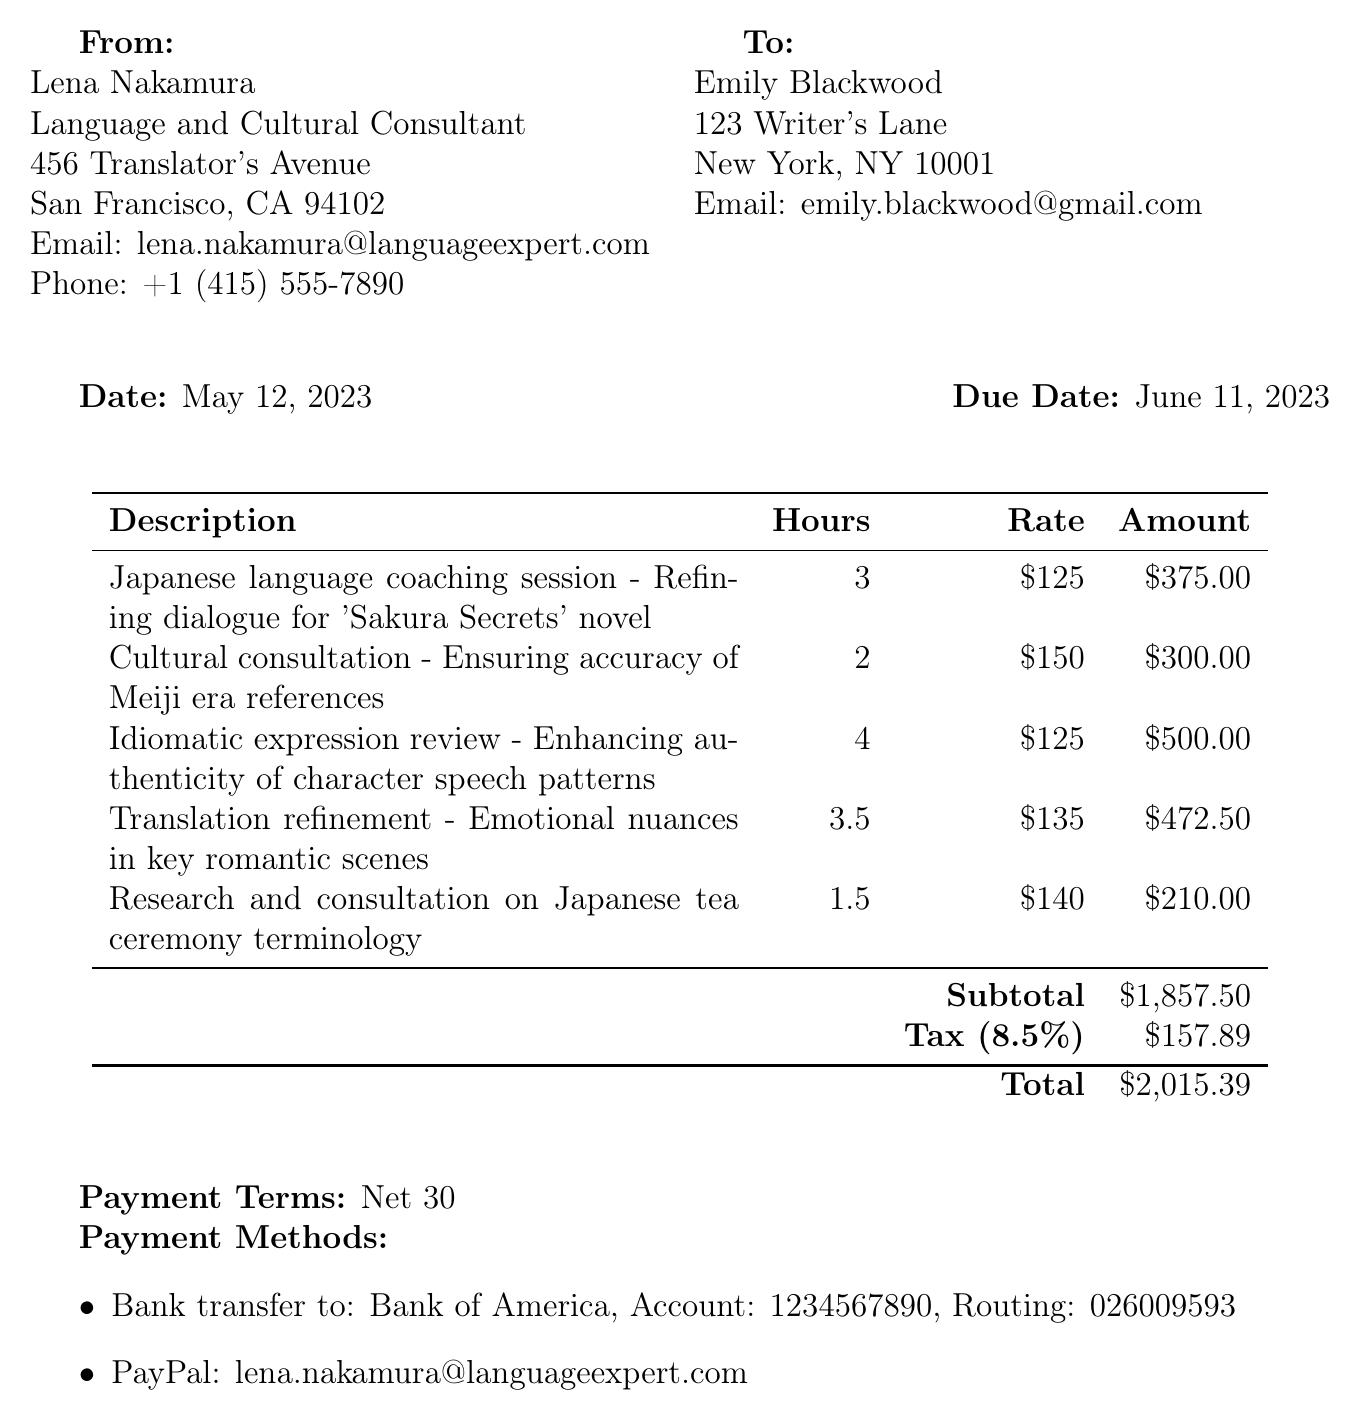what is the invoice number? The invoice number is explicitly stated at the top of the document, identifying it uniquely as INV-2023-0512.
Answer: INV-2023-0512 who is the service provider? The service provider is clearly listed in the document, including their name and title, which is Lena Nakamura, Language and Cultural Consultant.
Answer: Lena Nakamura what is the subtotal amount? The subtotal is shown in the table summarizing the services provided, and it amounts to $1,857.50.
Answer: $1,857.50 how many hours were spent on idiomatic expression review? The hours for this line item are specified in the table, showing a total of 4 hours allocated for idiomatic expression review.
Answer: 4 what is the tax rate? The tax rate is provided in the document and is stated as 8.5 percent.
Answer: 8.5% what is the due date of the invoice? The due date is clearly mentioned in the document, indicating when payment is expected to be made, specifically June 11, 2023.
Answer: June 11, 2023 what is the total amount due? The total amount is summarized at the bottom of the invoice, which is $2,015.39.
Answer: $2,015.39 how many hours were dedicated to researching the Japanese tea ceremony terminology? The hours allocated for this particular service are outlined in the invoice, indicating it took 1.5 hours.
Answer: 1.5 what are the payment methods listed? The payment methods provided in the document include specific options for payment, which consist of bank transfer and PayPal.
Answer: Bank transfer and PayPal 